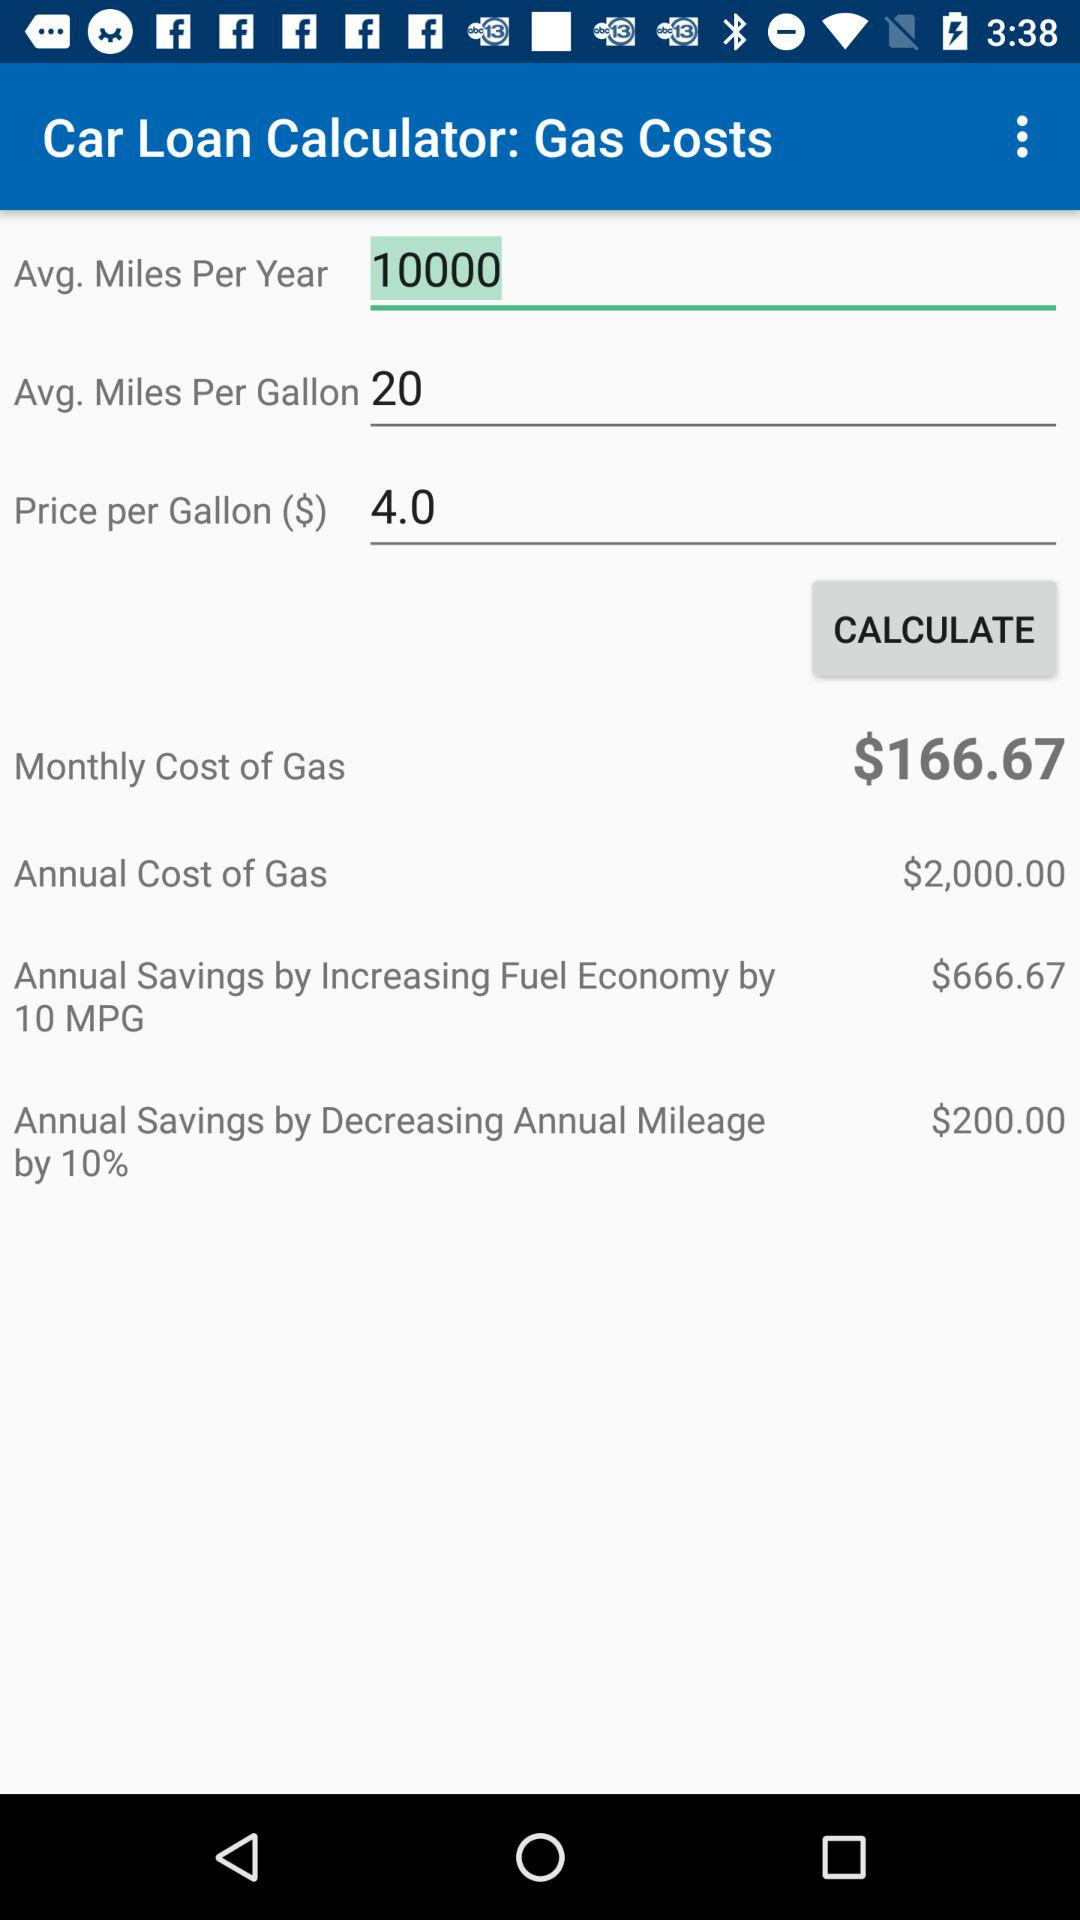How much will I save per year if I increase my fuel economy by 10 MPG?
Answer the question using a single word or phrase. $666.67 